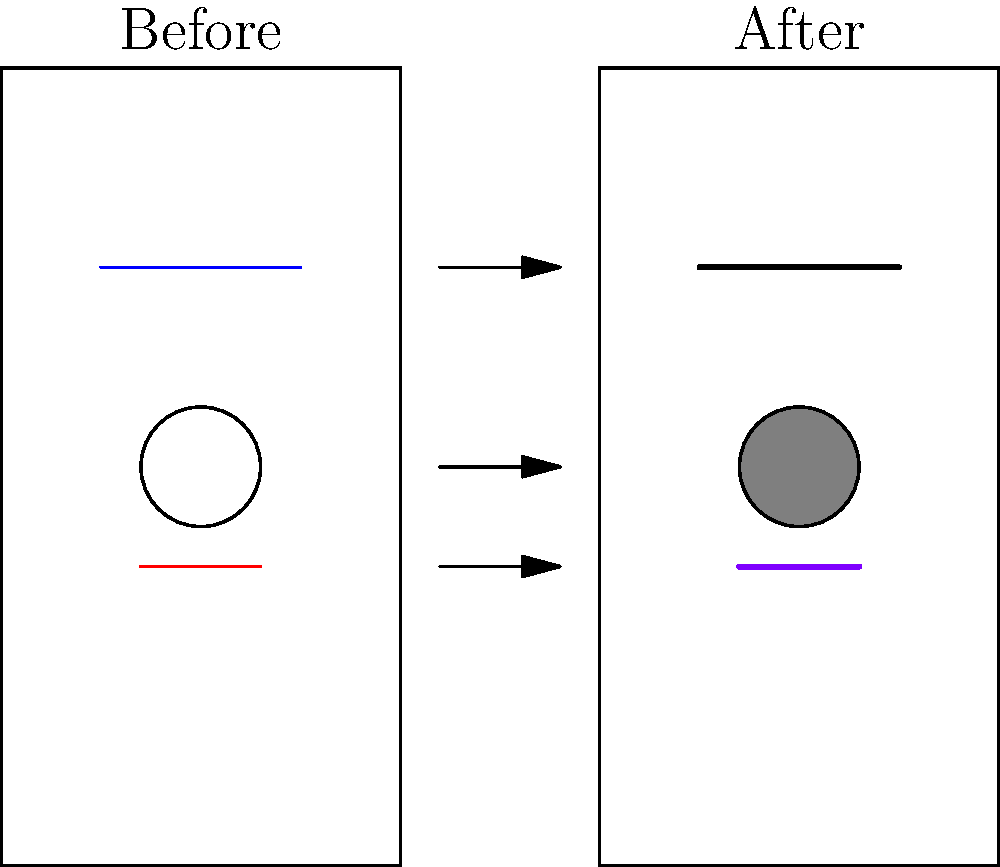In the side-by-side images of an actress's transformation, identify the three main differences in costume and makeup. How do these changes contribute to the character's visual development? To identify the differences and understand their contribution to the character's visual development, let's analyze the images step-by-step:

1. Hair color change:
   - Before: Blue line representing light-colored hair
   - After: Black, thicker line representing darker, possibly more voluminous hair
   Contribution: This change could indicate a shift in the character's personality, age, or circumstances.

2. Skin tone alteration:
   - Before: White circle representing fair skin
   - After: Gray-filled circle representing a darker or more weathered complexion
   Contribution: This change might suggest environmental factors, lifestyle changes, or a different ethnicity for the character.

3. Lip color modification:
   - Before: Red line representing natural or bright lip color
   - After: Purple, thicker line representing a darker, more dramatic lip color
   Contribution: This change could imply a shift in the character's style, confidence, or the era/setting of the story.

These visual transformations work together to create a new persona for the actress, allowing her to embody the character more fully. The combination of hair, skin, and makeup changes provides a comprehensive physical alteration that can significantly impact how the audience perceives the character's age, background, and personality.
Answer: Hair darkening, skin tone darkening, lip color deepening; creating a more dramatic, possibly older or weathered appearance. 